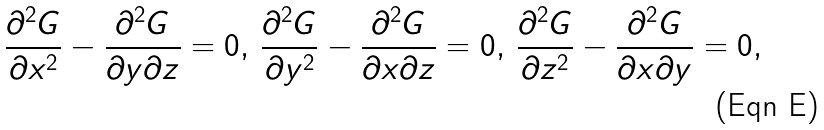Convert formula to latex. <formula><loc_0><loc_0><loc_500><loc_500>\frac { \partial ^ { 2 } G } { \partial x ^ { 2 } } - \frac { \partial ^ { 2 } G } { \partial y \partial z } = 0 , \, \frac { \partial ^ { 2 } G } { \partial y ^ { 2 } } - \frac { \partial ^ { 2 } G } { \partial x \partial z } = 0 , \, \frac { \partial ^ { 2 } G } { \partial z ^ { 2 } } - \frac { \partial ^ { 2 } G } { \partial x \partial y } = 0 ,</formula> 